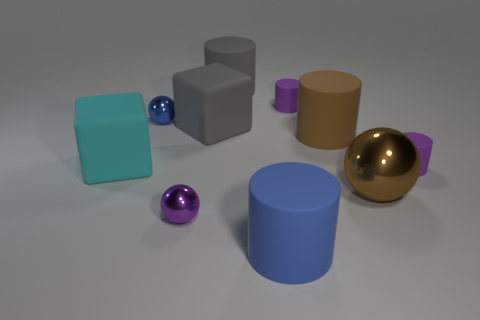How many other things are there of the same size as the blue rubber thing?
Give a very brief answer. 5. What is the material of the small object that is to the left of the big ball and in front of the big cyan rubber block?
Make the answer very short. Metal. Do the large metal ball and the large rubber cube that is left of the tiny purple shiny ball have the same color?
Provide a short and direct response. No. There is a blue metallic object that is the same shape as the purple metal object; what is its size?
Give a very brief answer. Small. What shape is the small object that is both behind the purple metal ball and in front of the large cyan thing?
Offer a very short reply. Cylinder. There is a brown shiny object; does it have the same size as the purple matte object to the right of the large shiny thing?
Provide a short and direct response. No. The big shiny thing that is the same shape as the tiny blue thing is what color?
Make the answer very short. Brown. There is a metal ball that is in front of the big metal sphere; does it have the same size as the shiny ball that is to the right of the gray rubber cylinder?
Provide a succinct answer. No. Do the big blue object and the large brown matte object have the same shape?
Make the answer very short. Yes. How many things are either small objects that are on the left side of the large gray matte cube or big brown matte cylinders?
Provide a short and direct response. 3. 